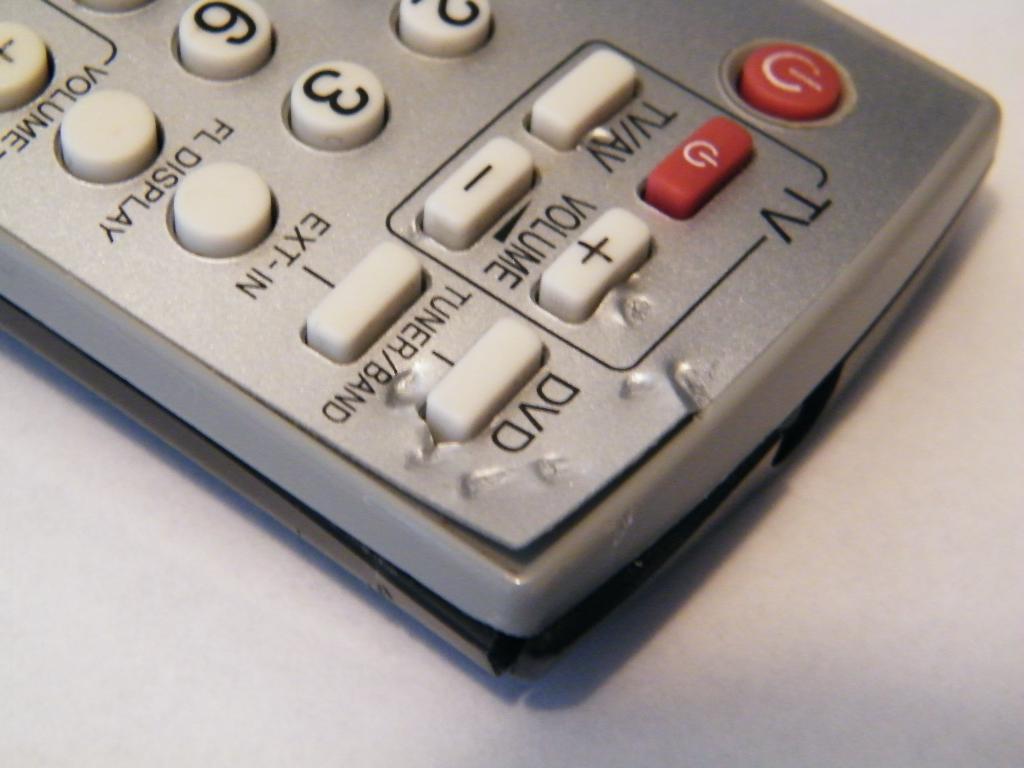What letters are above the red square button?
Ensure brevity in your answer.  Tv. What type of clicker is this for?
Your response must be concise. Tv. 